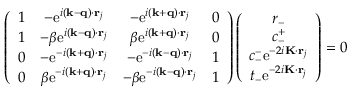<formula> <loc_0><loc_0><loc_500><loc_500>\begin{array} { r } { \left ( \begin{array} { c c c c } { 1 } & { - e ^ { i ( k - q ) \cdot r _ { j } } } & { - e ^ { i ( k + q ) \cdot r _ { j } } } & { 0 } \\ { 1 } & { - \beta e ^ { i ( k - q ) \cdot r _ { j } } } & { \beta e ^ { i ( k + q ) \cdot r _ { j } } } & { 0 } \\ { 0 } & { - e ^ { - i ( k + q ) \cdot r _ { j } } } & { - e ^ { - i ( k - q ) \cdot r _ { j } } } & { 1 } \\ { 0 } & { \beta e ^ { - i ( k + q ) \cdot r _ { j } } } & { - \beta e ^ { - i ( k - q ) \cdot r _ { j } } } & { 1 } \end{array} \right ) \left ( \begin{array} { c } { r _ { - } } \\ { c _ { - } ^ { + } } \\ { c _ { - } ^ { - } e ^ { - 2 i K \cdot r _ { j } } } \\ { t _ { - } e ^ { - 2 i K \cdot r _ { j } } } \end{array} \right ) = 0 } \end{array}</formula> 